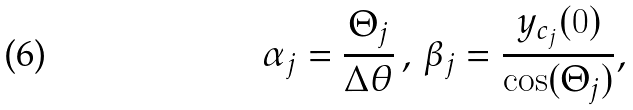<formula> <loc_0><loc_0><loc_500><loc_500>\alpha _ { j } = \frac { \Theta _ { j } } { \Delta \theta } \, , \, \beta _ { j } = \frac { y _ { c _ { j } } ( 0 ) } { \cos ( \Theta _ { j } ) } ,</formula> 